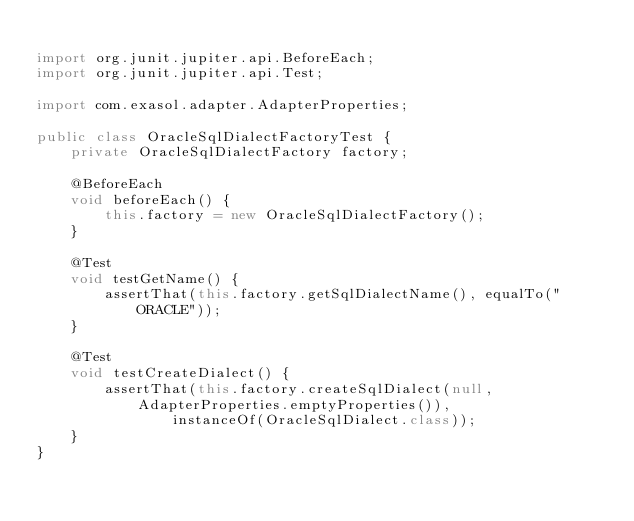<code> <loc_0><loc_0><loc_500><loc_500><_Java_>
import org.junit.jupiter.api.BeforeEach;
import org.junit.jupiter.api.Test;

import com.exasol.adapter.AdapterProperties;

public class OracleSqlDialectFactoryTest {
    private OracleSqlDialectFactory factory;

    @BeforeEach
    void beforeEach() {
        this.factory = new OracleSqlDialectFactory();
    }

    @Test
    void testGetName() {
        assertThat(this.factory.getSqlDialectName(), equalTo("ORACLE"));
    }

    @Test
    void testCreateDialect() {
        assertThat(this.factory.createSqlDialect(null, AdapterProperties.emptyProperties()),
                instanceOf(OracleSqlDialect.class));
    }
}</code> 